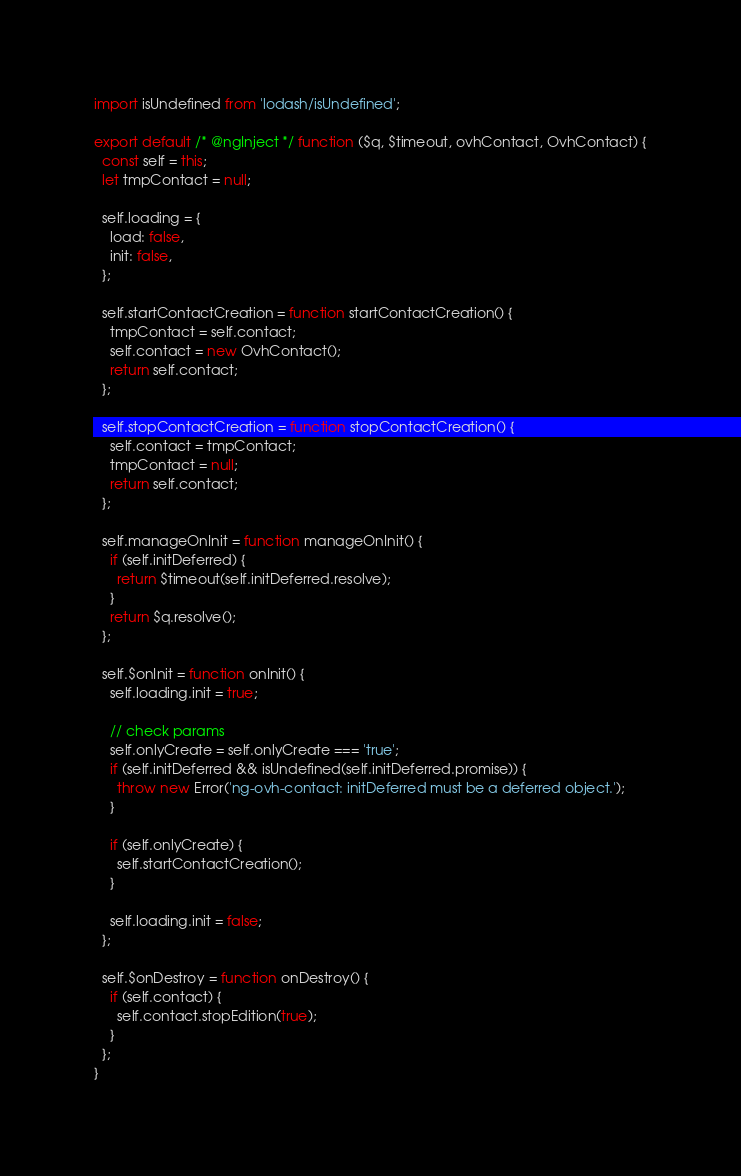Convert code to text. <code><loc_0><loc_0><loc_500><loc_500><_JavaScript_>import isUndefined from 'lodash/isUndefined';

export default /* @ngInject */ function ($q, $timeout, ovhContact, OvhContact) {
  const self = this;
  let tmpContact = null;

  self.loading = {
    load: false,
    init: false,
  };

  self.startContactCreation = function startContactCreation() {
    tmpContact = self.contact;
    self.contact = new OvhContact();
    return self.contact;
  };

  self.stopContactCreation = function stopContactCreation() {
    self.contact = tmpContact;
    tmpContact = null;
    return self.contact;
  };

  self.manageOnInit = function manageOnInit() {
    if (self.initDeferred) {
      return $timeout(self.initDeferred.resolve);
    }
    return $q.resolve();
  };

  self.$onInit = function onInit() {
    self.loading.init = true;

    // check params
    self.onlyCreate = self.onlyCreate === 'true';
    if (self.initDeferred && isUndefined(self.initDeferred.promise)) {
      throw new Error('ng-ovh-contact: initDeferred must be a deferred object.');
    }

    if (self.onlyCreate) {
      self.startContactCreation();
    }

    self.loading.init = false;
  };

  self.$onDestroy = function onDestroy() {
    if (self.contact) {
      self.contact.stopEdition(true);
    }
  };
}
</code> 